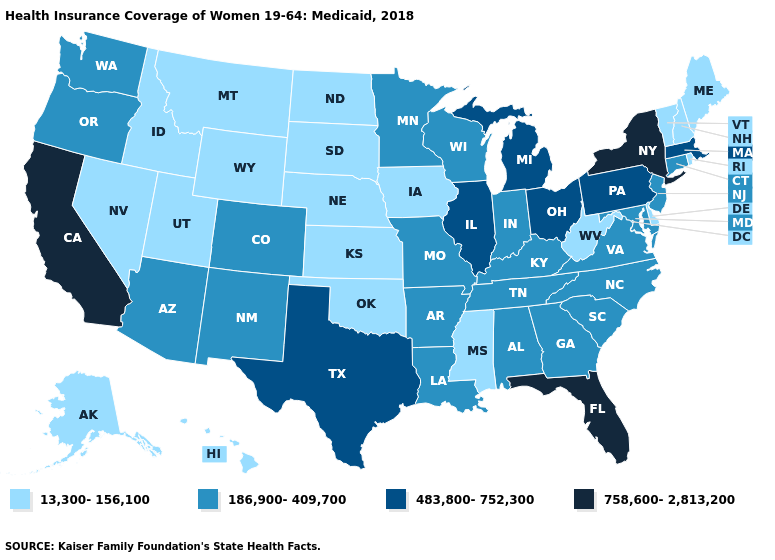Does California have the highest value in the USA?
Short answer required. Yes. What is the lowest value in states that border Connecticut?
Be succinct. 13,300-156,100. Name the states that have a value in the range 13,300-156,100?
Quick response, please. Alaska, Delaware, Hawaii, Idaho, Iowa, Kansas, Maine, Mississippi, Montana, Nebraska, Nevada, New Hampshire, North Dakota, Oklahoma, Rhode Island, South Dakota, Utah, Vermont, West Virginia, Wyoming. Name the states that have a value in the range 483,800-752,300?
Short answer required. Illinois, Massachusetts, Michigan, Ohio, Pennsylvania, Texas. Among the states that border Illinois , which have the lowest value?
Quick response, please. Iowa. What is the value of Florida?
Be succinct. 758,600-2,813,200. What is the value of Montana?
Quick response, please. 13,300-156,100. Among the states that border Illinois , does Kentucky have the highest value?
Be succinct. Yes. What is the lowest value in states that border Minnesota?
Be succinct. 13,300-156,100. What is the value of New Mexico?
Quick response, please. 186,900-409,700. What is the highest value in the Northeast ?
Quick response, please. 758,600-2,813,200. Name the states that have a value in the range 758,600-2,813,200?
Be succinct. California, Florida, New York. Name the states that have a value in the range 483,800-752,300?
Concise answer only. Illinois, Massachusetts, Michigan, Ohio, Pennsylvania, Texas. Does California have the highest value in the USA?
Quick response, please. Yes. Name the states that have a value in the range 186,900-409,700?
Short answer required. Alabama, Arizona, Arkansas, Colorado, Connecticut, Georgia, Indiana, Kentucky, Louisiana, Maryland, Minnesota, Missouri, New Jersey, New Mexico, North Carolina, Oregon, South Carolina, Tennessee, Virginia, Washington, Wisconsin. 